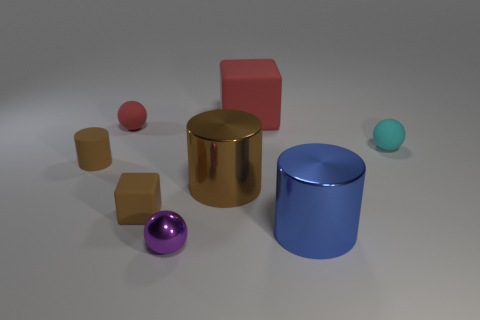There is a brown thing that is to the right of the tiny cylinder and behind the small cube; how big is it?
Offer a very short reply. Large. What is the shape of the tiny matte thing that is to the right of the small red sphere and to the left of the tiny cyan rubber thing?
Ensure brevity in your answer.  Cube. Are there any large red matte things that are in front of the matte sphere that is to the right of the red thing left of the small metal thing?
Provide a succinct answer. No. What number of things are either objects on the left side of the tiny cyan sphere or red matte spheres on the left side of the brown shiny cylinder?
Ensure brevity in your answer.  7. Does the tiny sphere that is on the right side of the brown metallic cylinder have the same material as the red block?
Ensure brevity in your answer.  Yes. There is a tiny object that is both in front of the large brown thing and behind the small metal object; what is its material?
Provide a succinct answer. Rubber. There is a large metal thing left of the red object that is behind the tiny red thing; what is its color?
Ensure brevity in your answer.  Brown. What material is the tiny red object that is the same shape as the small purple thing?
Make the answer very short. Rubber. What is the color of the big metallic object in front of the brown thing that is in front of the shiny cylinder that is behind the brown rubber cube?
Provide a short and direct response. Blue. What number of things are either cyan matte spheres or big gray matte objects?
Your answer should be compact. 1. 